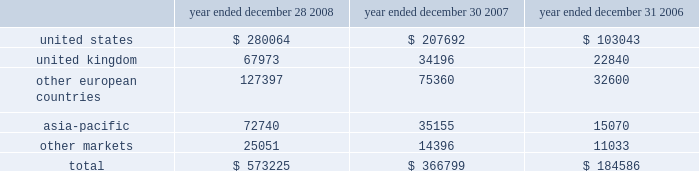Executive deferred compensation plan for the company 2019s executives and members of the board of directors , the company adopted the illumina , inc .
Deferred compensation plan ( the plan ) that became effective january 1 , 2008 .
Eligible participants can contribute up to 80% ( 80 % ) of their base salary and 100% ( 100 % ) of all other forms of compensation into the plan , including bonus , commission and director fees .
The company has agreed to credit the participants 2019 contributions with earnings that reflect the performance of certain independent investment funds .
On a discretionary basis , the company may also make employer contributions to participant accounts in any amount determined by the company .
The vesting schedules of employer contributions are at the sole discretion of the compensation committee .
However , all employer contributions shall become 100% ( 100 % ) vested upon the occurrence of the participant 2019s disability , death or retirement or a change in control of the company .
The benefits under this plan are unsecured .
Participants are generally eligible to receive payment of their vested benefit at the end of their elected deferral period or after termination of their employment with the company for any reason or at a later date to comply with the restrictions of section 409a .
As of december 28 , 2008 , no employer contributions were made to the plan .
In january 2008 , the company also established a rabbi trust for the benefit of its directors and executives under the plan .
In accordance with fasb interpretation ( fin ) no .
46 , consolidation of variable interest entities , an interpretation of arb no .
51 , and eitf 97-14 , accounting for deferred compensation arrangements where amounts earned are held in a rabbi trust and invested , the company has included the assets of the rabbi trust in its consolidated balance sheet since the trust 2019s inception .
As of december 28 , 2008 , the assets of the trust and liabilities of the company were $ 1.3 million .
The assets and liabilities are classified as other assets and accrued liabilities , respectively , on the company 2019s balance sheet as of december 28 , 2008 .
Changes in the values of the assets held by the rabbi trust accrue to the company .
14 .
Segment information , geographic data and significant customers during the first quarter of 2008 , the company reorganized its operating structure into a newly created life sciences business unit , which includes all products and services related to the research market , namely the beadarray , beadxpress and sequencing product lines .
The company also created a diagnostics business unit to focus on the emerging opportunity in molecular diagnostics .
For the year ended december 28 , 2008 , the company had limited activity related to the diagnostics business unit , and operating results were reported on an aggregate basis to the chief operating decision maker of the company , the chief executive officer .
In accordance with sfas no .
131 , disclosures about segments of an enterprise and related information , the company operated in one reportable segment for the year ended december 28 , 2008 .
The company had revenue in the following regions for the years ended december 28 , 2008 , december 30 , 2007 and december 31 , 2006 ( in thousands ) : year ended december 28 , year ended december 30 , year ended december 31 .
Net revenues are attributable to geographic areas based on the region of destination .
Illumina , inc .
Notes to consolidated financial statements 2014 ( continued ) .
For the year ended december 28 , 2008 what was the percent of the united states revenues to the total? 
Rationale: for the year ended december 28 , 2008 the total revenues were made of 48.9 % united states revenuers
Computations: (280064 / 573225)
Answer: 0.48858. 